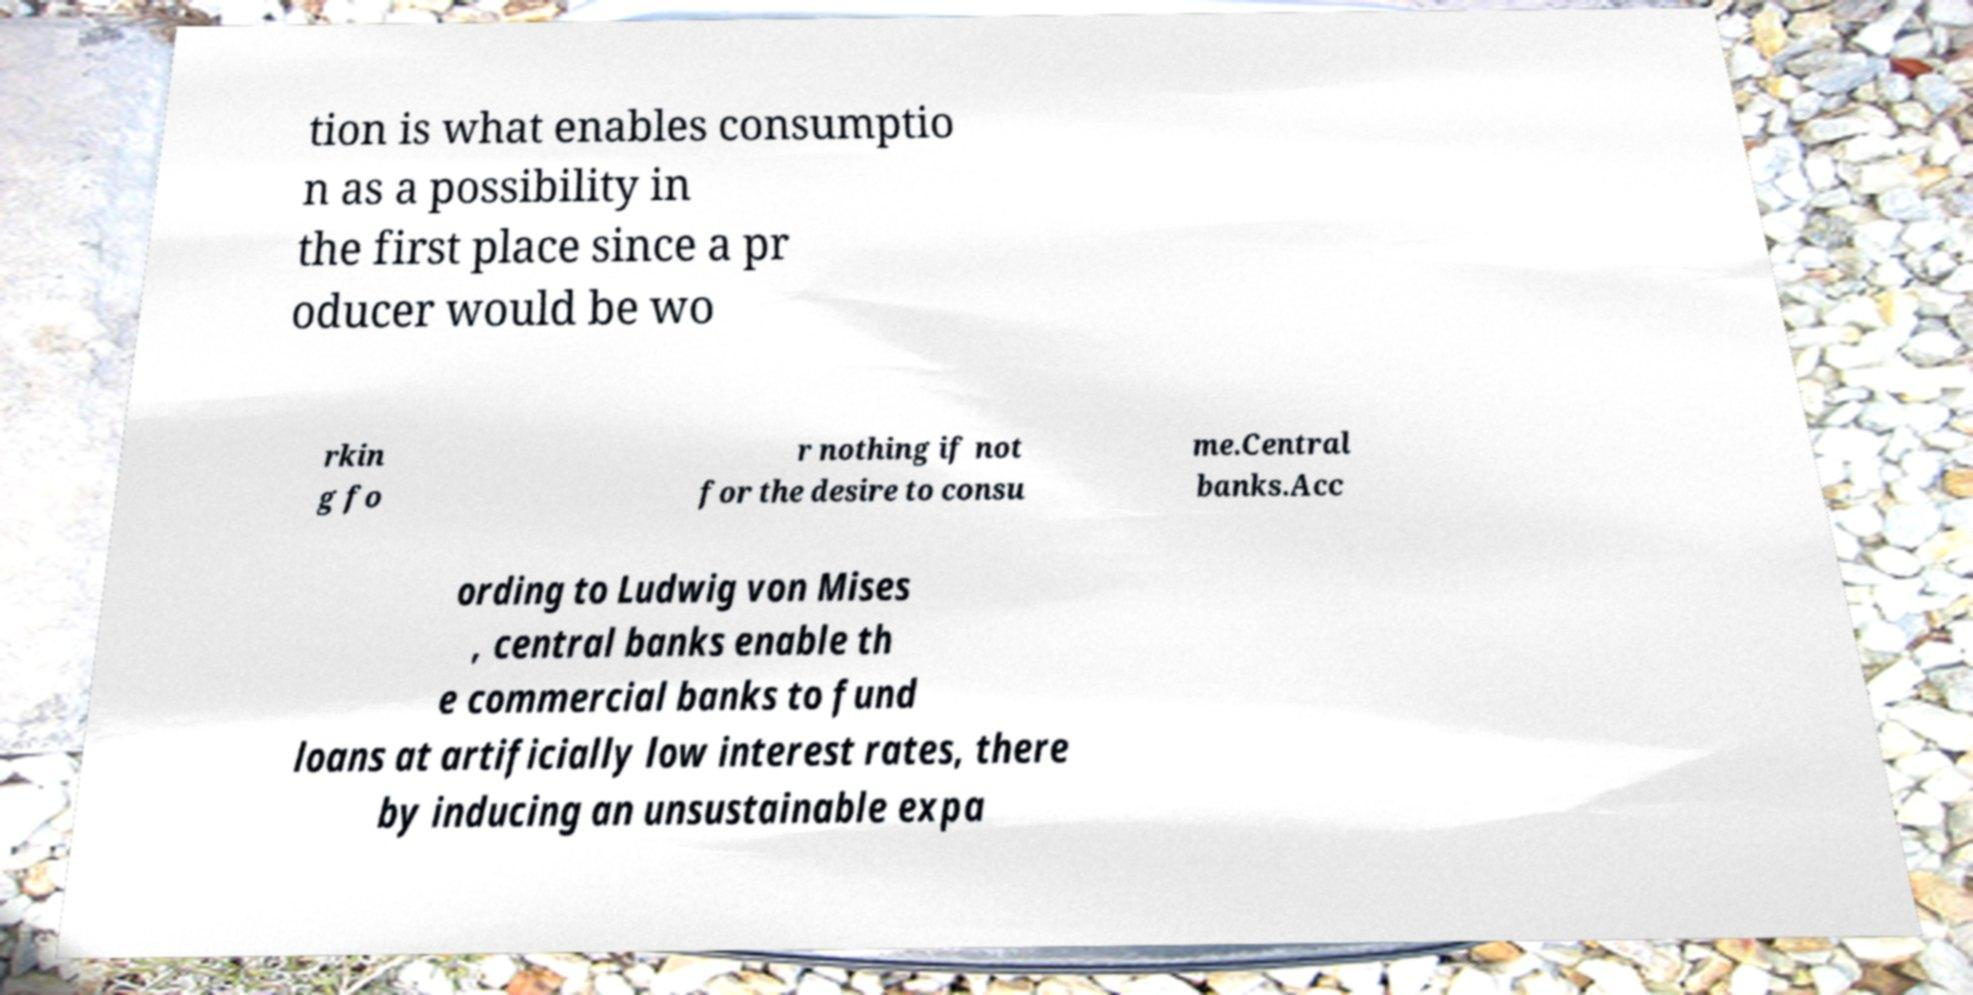Could you extract and type out the text from this image? tion is what enables consumptio n as a possibility in the first place since a pr oducer would be wo rkin g fo r nothing if not for the desire to consu me.Central banks.Acc ording to Ludwig von Mises , central banks enable th e commercial banks to fund loans at artificially low interest rates, there by inducing an unsustainable expa 